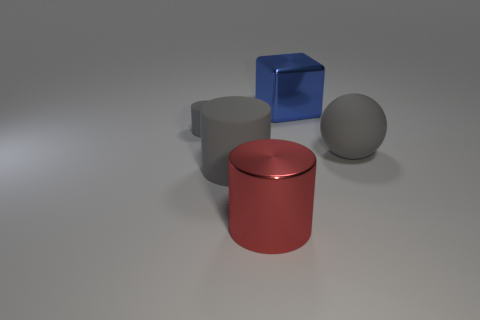Is there any object that stands out or looks out of place? The blue cube stands out due to its vibrant color and shiny surface, contrasting with the other objects which have muted colors and a matte finish. 